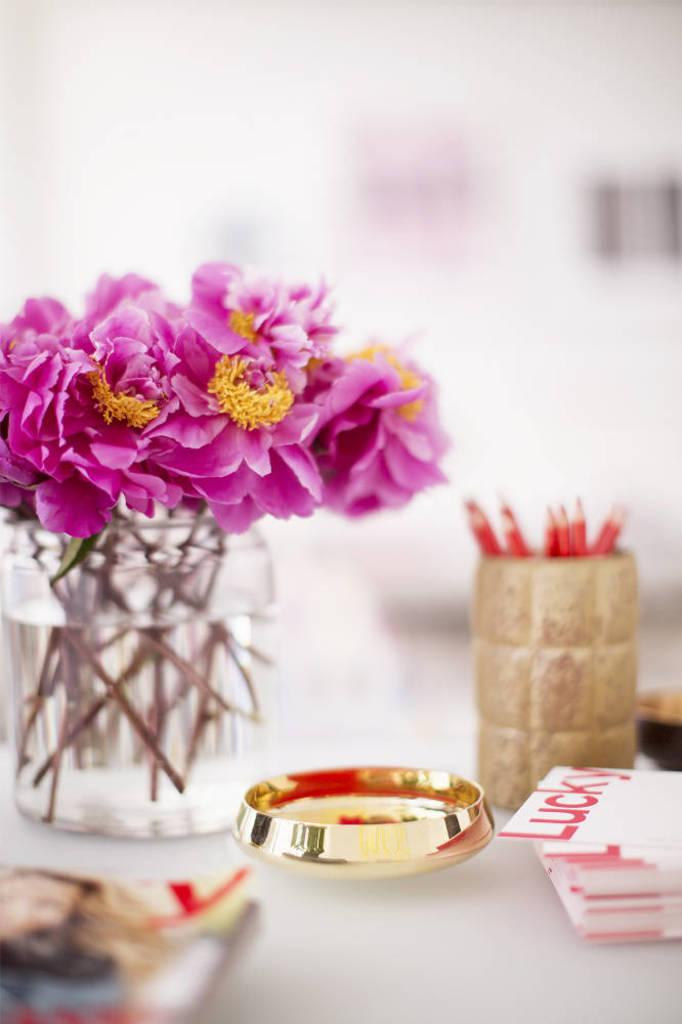What type of flowers can be seen in the bottle in the image? There are pink color flowers in a bottle in the image. What items are stored in a box in the image? There are pencils in a box in the image. What objects are on the table in the image? There are bowls and papers on the table in the image. What decorative items can be seen on the wall at the back in the image? There are frames on the wall at the back in the image. How many eggs are being held by the hen in the image? There is no hen or eggs present in the image. What type of tooth is visible in the image? There is no tooth visible in the image. 